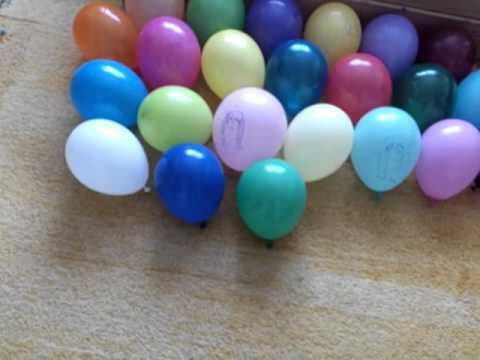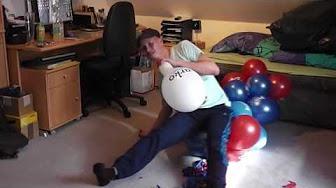The first image is the image on the left, the second image is the image on the right. For the images displayed, is the sentence "The right image shows a foot in a stilleto heeled shoe above a green balloon, with various colors of balloons around it on the floor." factually correct? Answer yes or no. No. The first image is the image on the left, the second image is the image on the right. For the images shown, is this caption "In at least one image there is a woman with a pair of high heels above a balloon." true? Answer yes or no. No. 